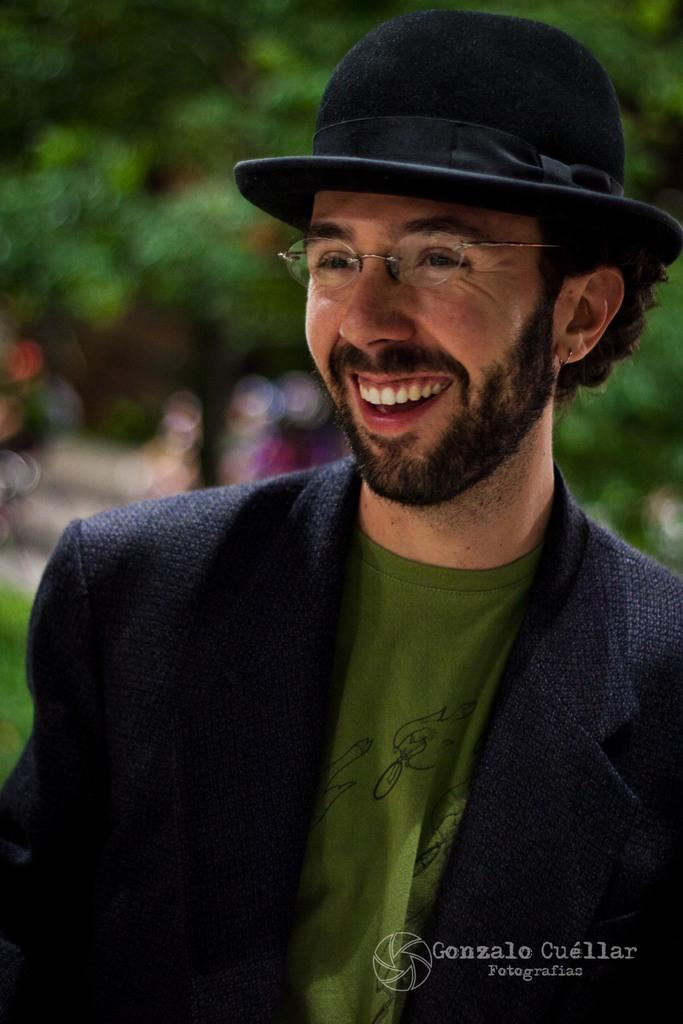Who or what is present in the image? There is a person in the image. What is the person doing or expressing? The person is smiling. Can you describe the background of the image? The background of the image is blurred. What is located at the bottom of the image? There is text at the bottom of the image. What type of honey is being used by the pets in the science experiment in the image? There is no honey, pets, or science experiment present in the image. 